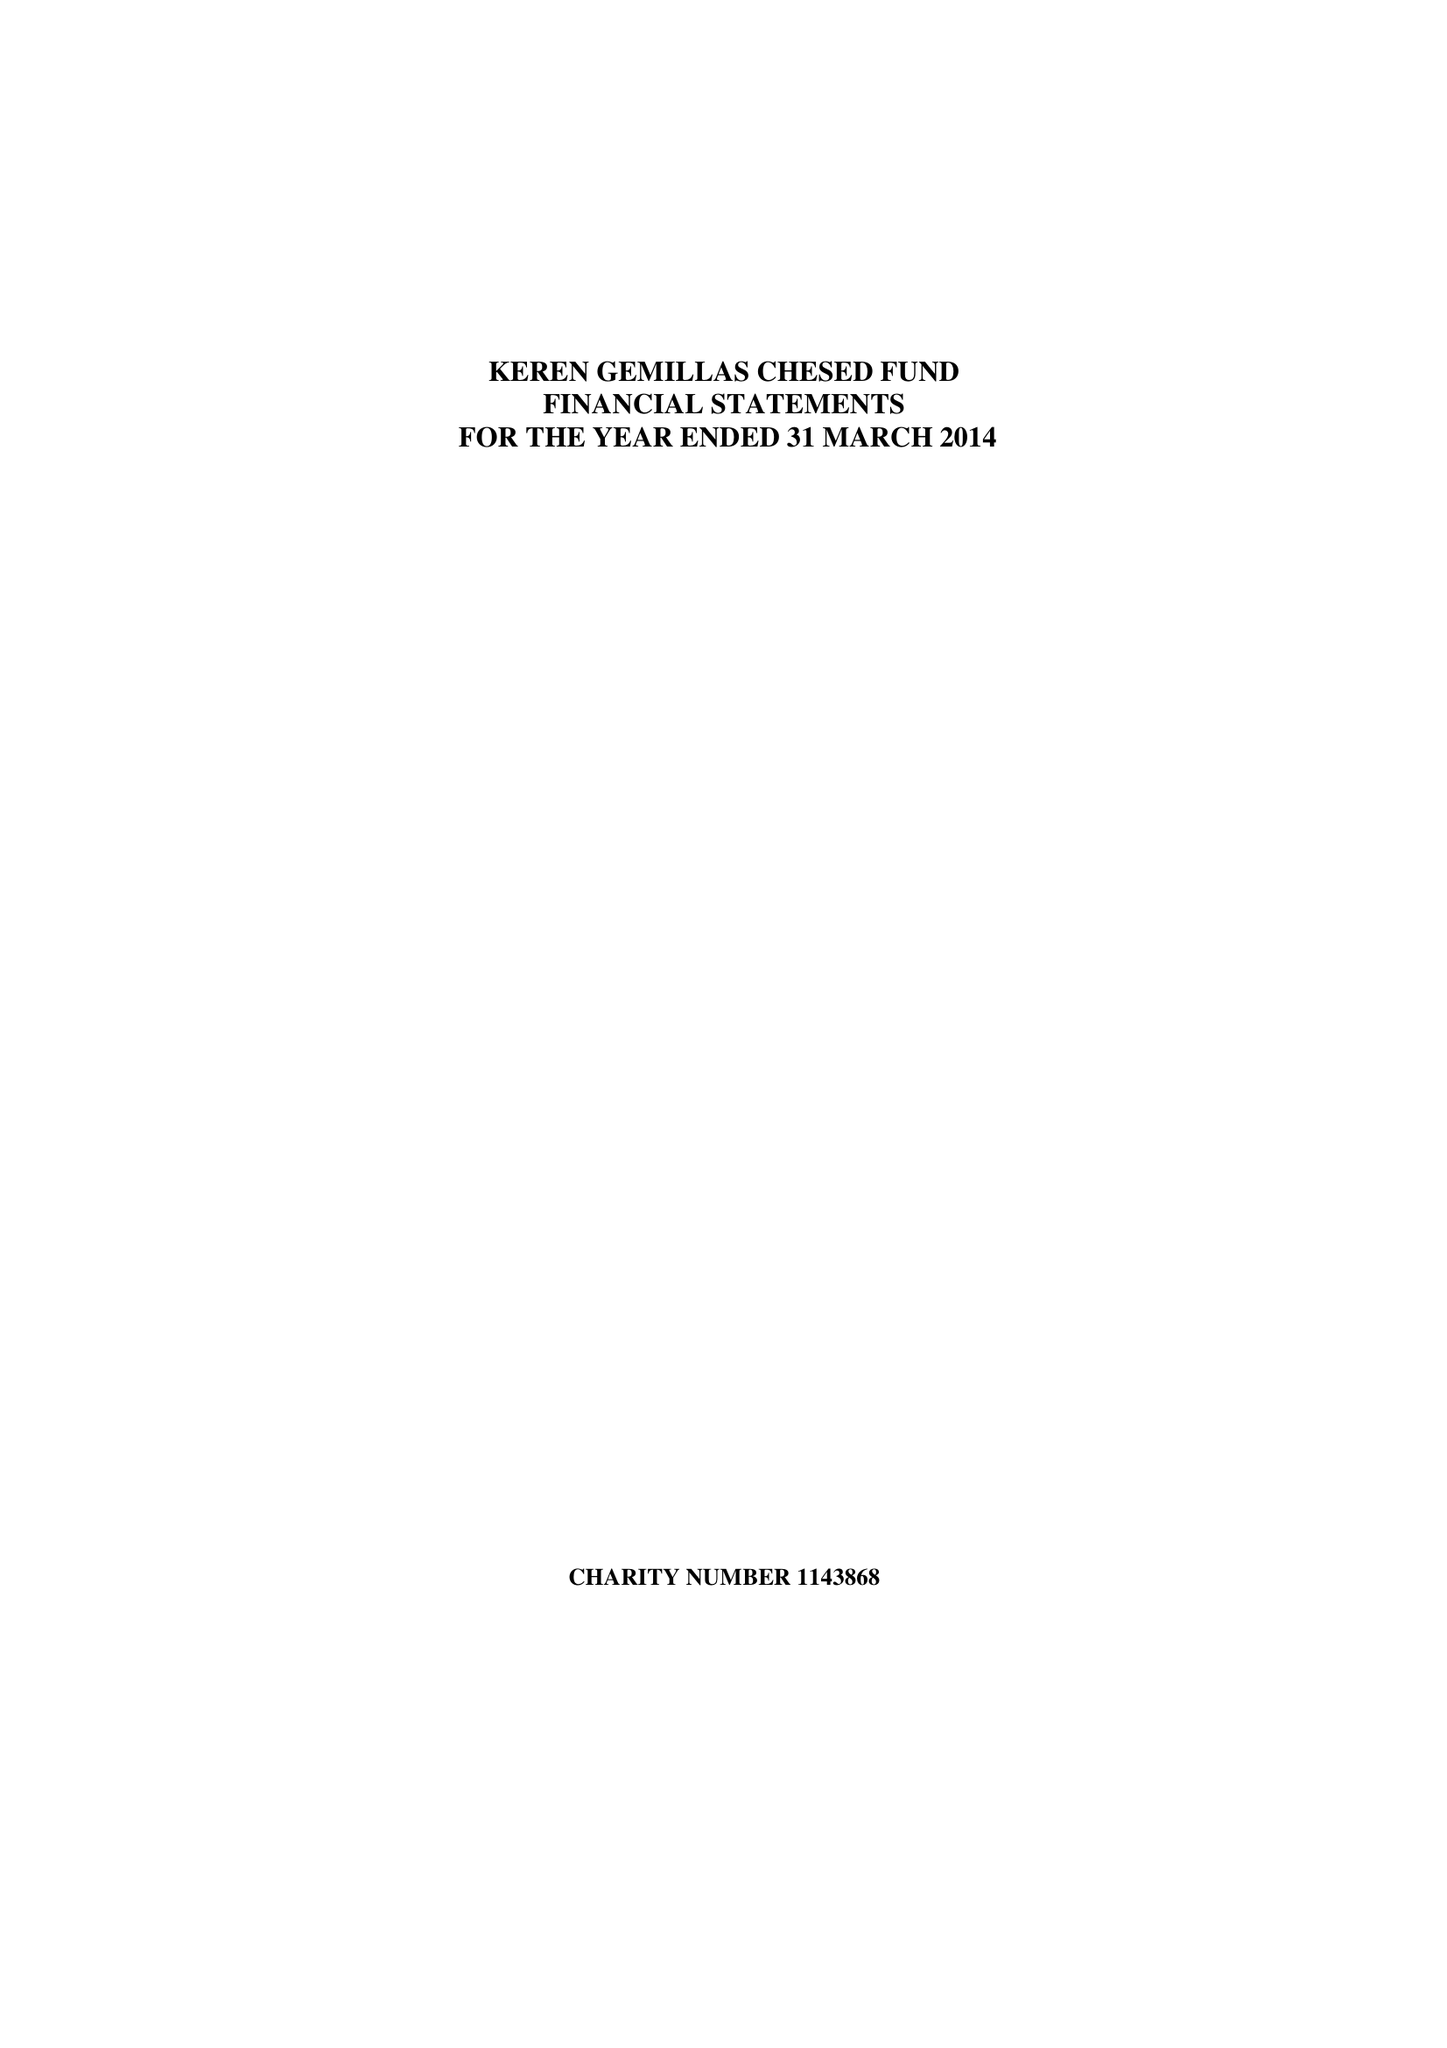What is the value for the charity_number?
Answer the question using a single word or phrase. 1143868 